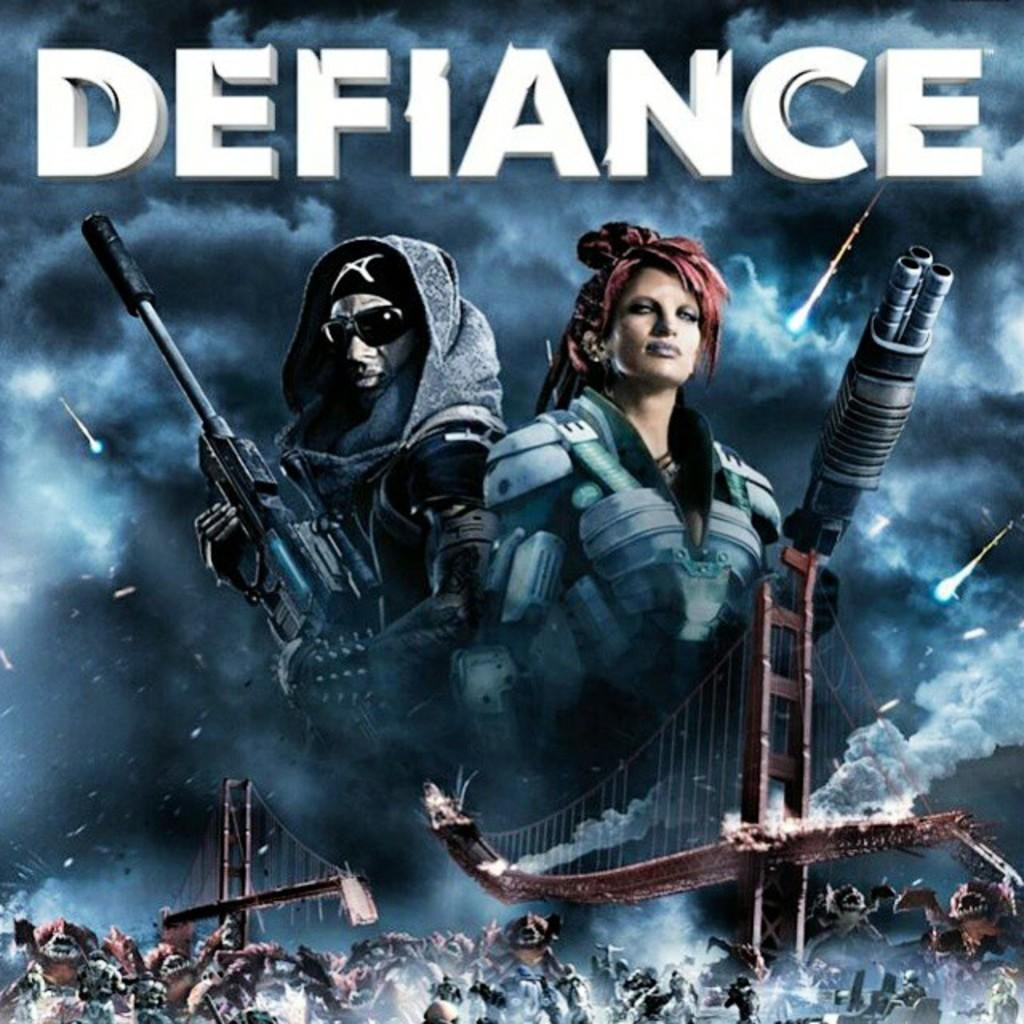<image>
Summarize the visual content of the image. A poster for the game Defiance showing two people with guns and a battle scene. 